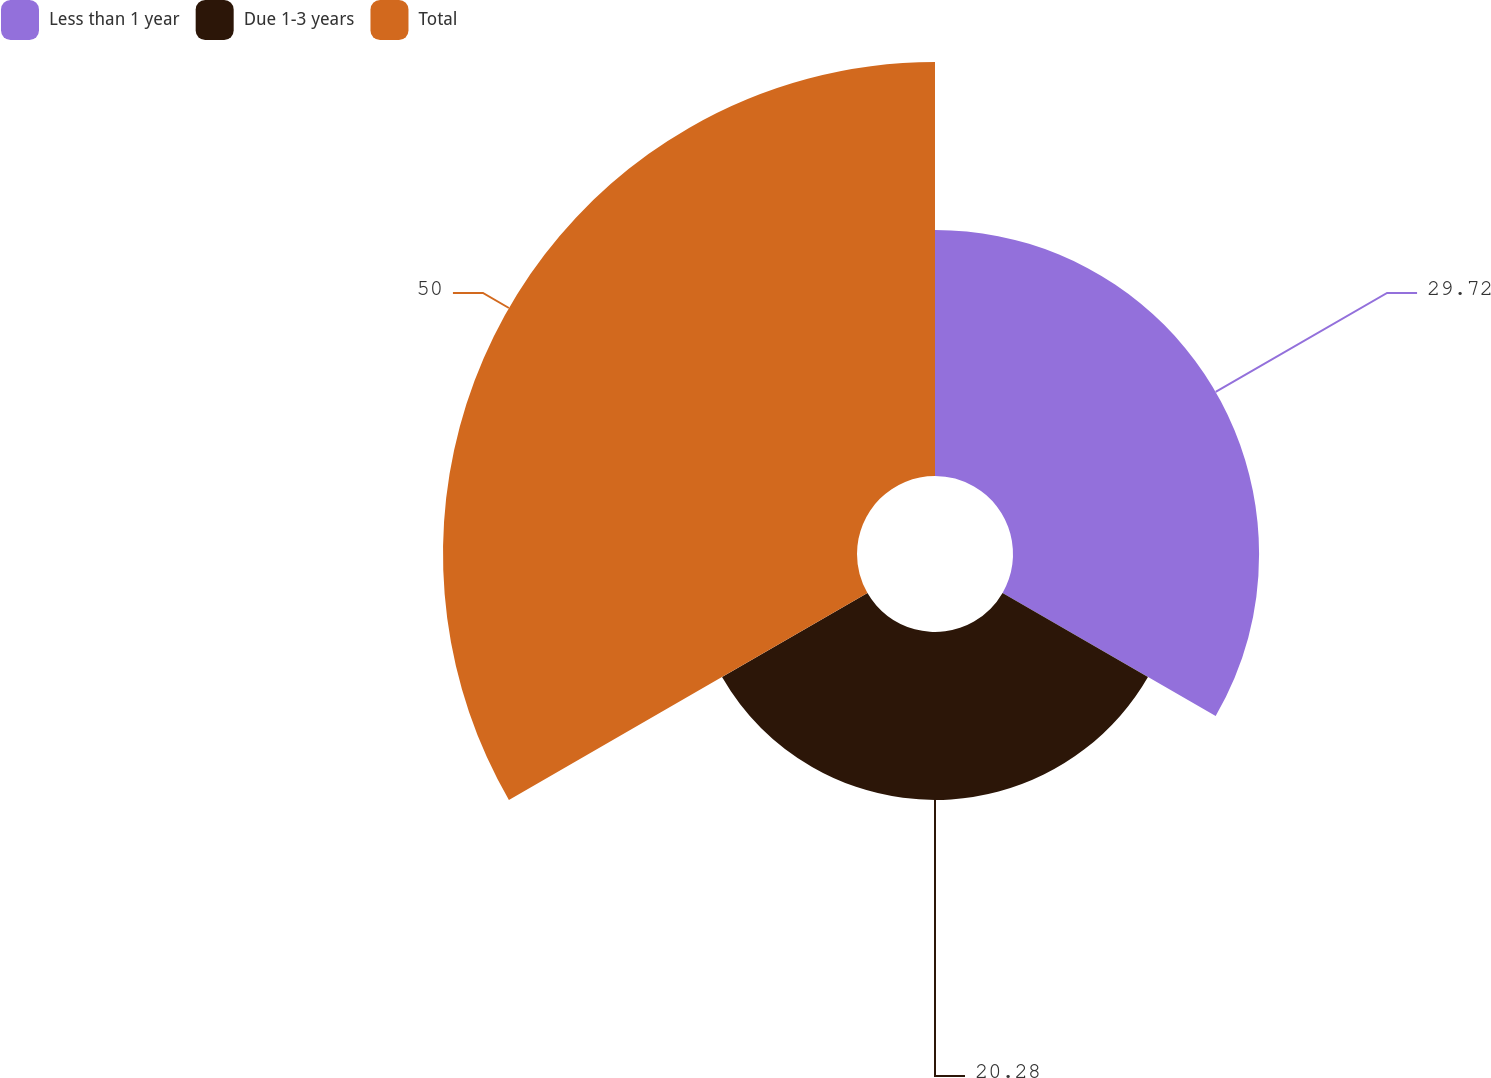Convert chart to OTSL. <chart><loc_0><loc_0><loc_500><loc_500><pie_chart><fcel>Less than 1 year<fcel>Due 1-3 years<fcel>Total<nl><fcel>29.72%<fcel>20.28%<fcel>50.0%<nl></chart> 